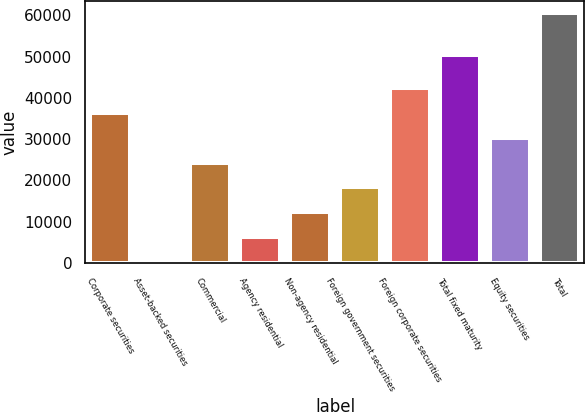Convert chart. <chart><loc_0><loc_0><loc_500><loc_500><bar_chart><fcel>Corporate securities<fcel>Asset-backed securities<fcel>Commercial<fcel>Agency residential<fcel>Non-agency residential<fcel>Foreign government securities<fcel>Foreign corporate securities<fcel>Total fixed maturity<fcel>Equity securities<fcel>Total<nl><fcel>36417.4<fcel>211<fcel>24348.6<fcel>6245.4<fcel>12279.8<fcel>18314.2<fcel>42451.8<fcel>50304<fcel>30383<fcel>60555<nl></chart> 